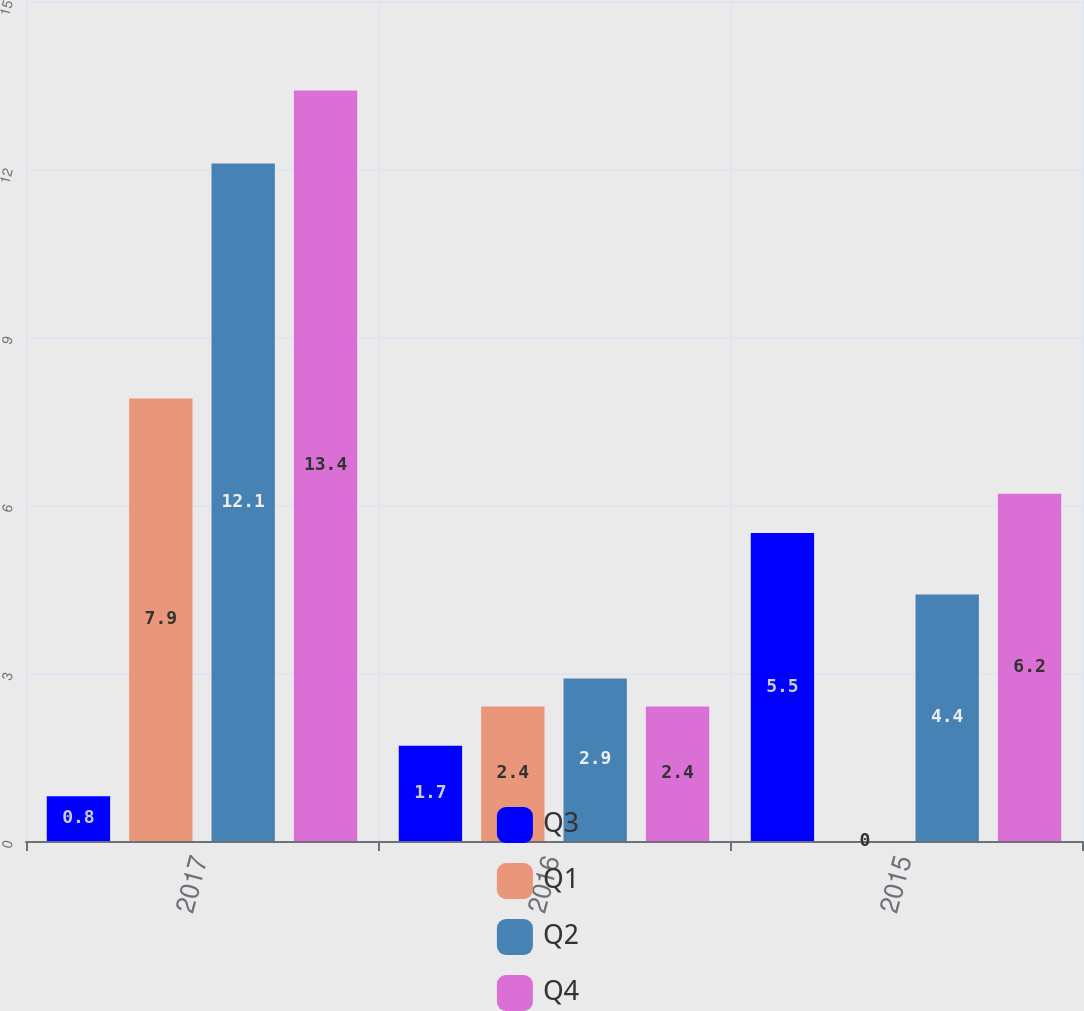<chart> <loc_0><loc_0><loc_500><loc_500><stacked_bar_chart><ecel><fcel>2017<fcel>2016<fcel>2015<nl><fcel>Q3<fcel>0.8<fcel>1.7<fcel>5.5<nl><fcel>Q1<fcel>7.9<fcel>2.4<fcel>0<nl><fcel>Q2<fcel>12.1<fcel>2.9<fcel>4.4<nl><fcel>Q4<fcel>13.4<fcel>2.4<fcel>6.2<nl></chart> 